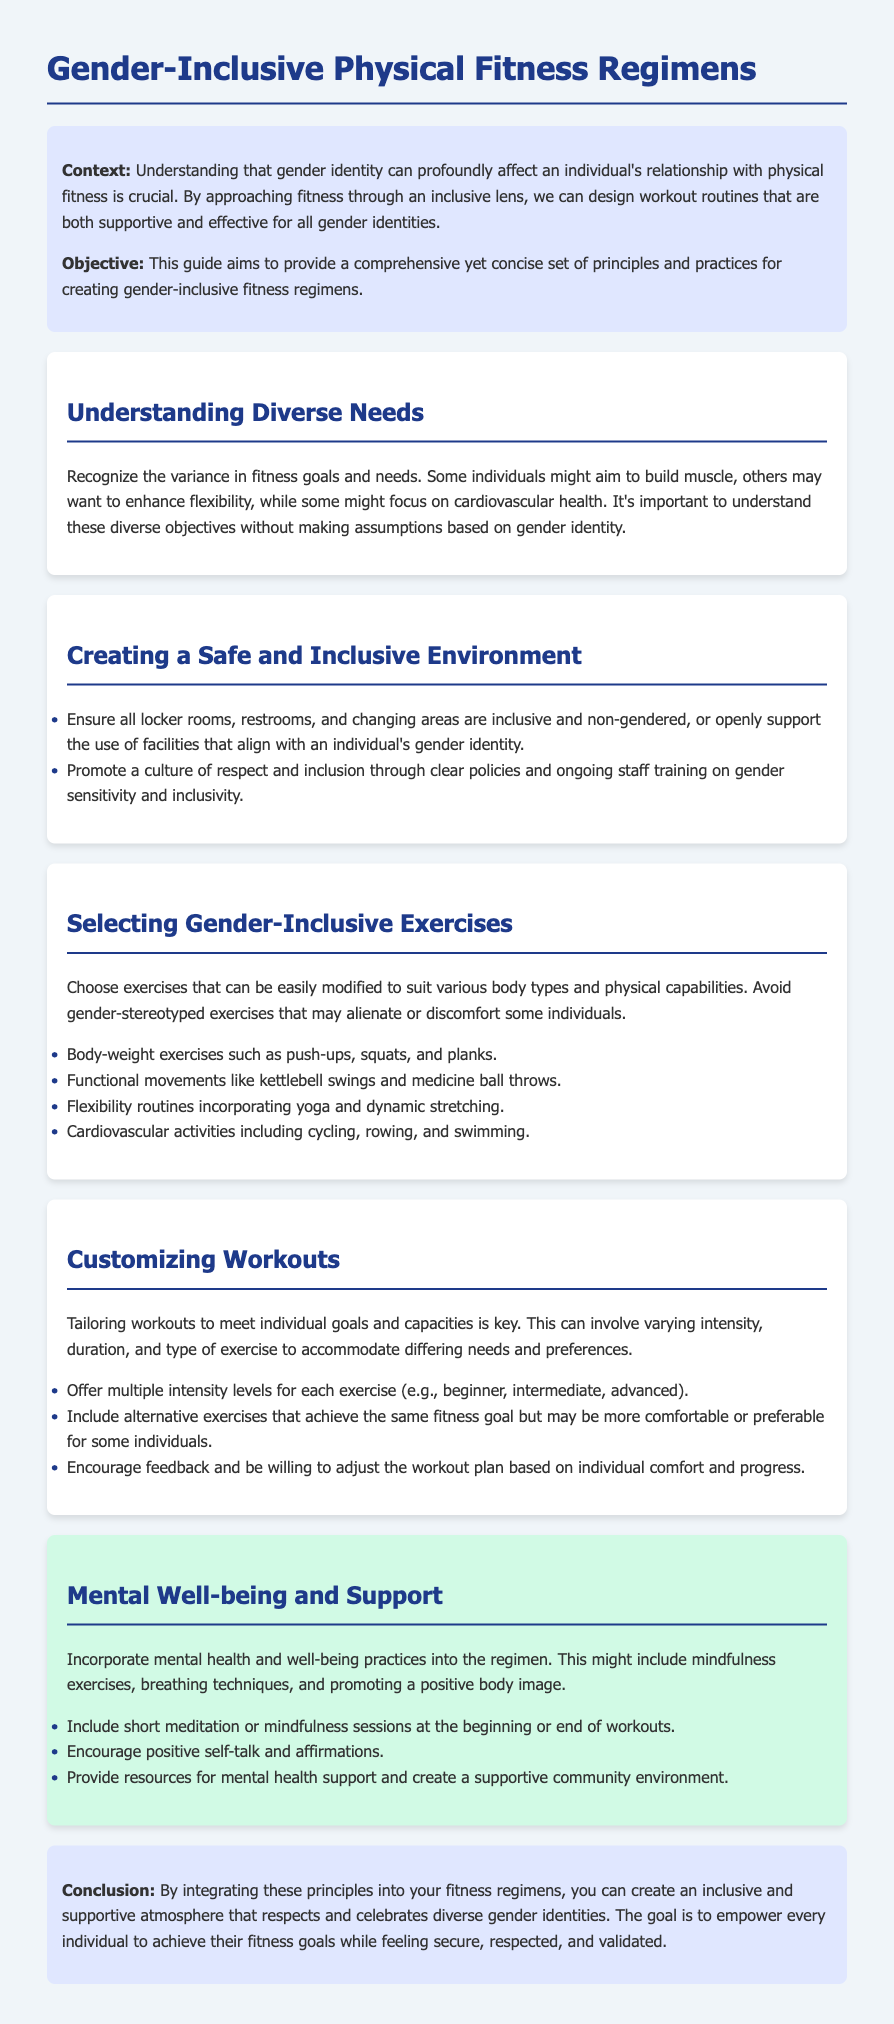what is the title of the document? The title is prominently displayed at the top of the document, indicating the focus on inclusive practices.
Answer: Gender-Inclusive Physical Fitness Regimens what is the primary context of this guide? The guide introduces the importance of understanding the impact of gender identity on physical fitness and a supportive approach to fitness.
Answer: Understanding that gender identity can profoundly affect an individual's relationship with physical fitness is crucial what type of environment is recommended for fitness? This section emphasizes the need for facilities that are supportive of diverse gender identities and accommodating to all individuals.
Answer: Safe and Inclusive Environment how many types of exercises are mentioned? The document lists four types of exercises that are appropriate for an inclusive fitness regimen.
Answer: Four what is one principle for customizing workouts? Tailoring workouts is key to meet individual needs, which may include altering intensity and type of exercise.
Answer: Varying intensity what kind of mental health practices are included in the regimen? This section suggests various mental health practices to support overall well-being alongside physical fitness.
Answer: Mindfulness exercises what is the conclusion about integrating principles into fitness regimens? The conclusion emphasizes the goal of creating an inclusive atmosphere that respects and celebrates diverse identities.
Answer: Empower every individual to achieve their fitness goals what should be included at the beginning or end of workouts? This is part of incorporating mental health practices within physical fitness regimens to enhance the experience.
Answer: Meditation or mindfulness sessions how does the guide suggest achieving positive body image? This involves encouraging behaviors and practices that promote self-acceptance and positivity in one's body.
Answer: Positive self-talk and affirmations 